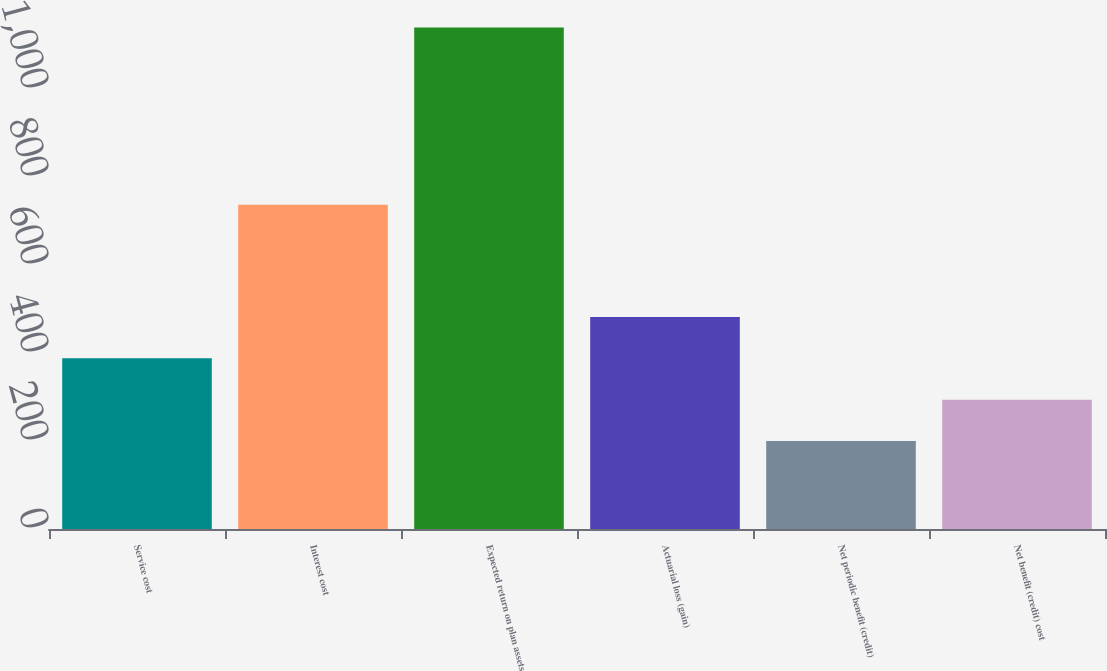<chart> <loc_0><loc_0><loc_500><loc_500><bar_chart><fcel>Service cost<fcel>Interest cost<fcel>Expected return on plan assets<fcel>Actuarial loss (gain)<fcel>Net periodic benefit (credit)<fcel>Net benefit (credit) cost<nl><fcel>388<fcel>737<fcel>1140<fcel>482<fcel>200<fcel>294<nl></chart> 